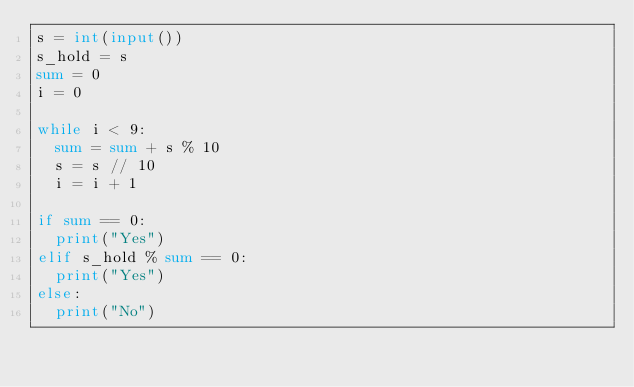<code> <loc_0><loc_0><loc_500><loc_500><_Python_>s = int(input())
s_hold = s
sum = 0
i = 0

while i < 9:
  sum = sum + s % 10
  s = s // 10
  i = i + 1

if sum == 0:
  print("Yes")
elif s_hold % sum == 0:
  print("Yes")
else:
  print("No")
</code> 